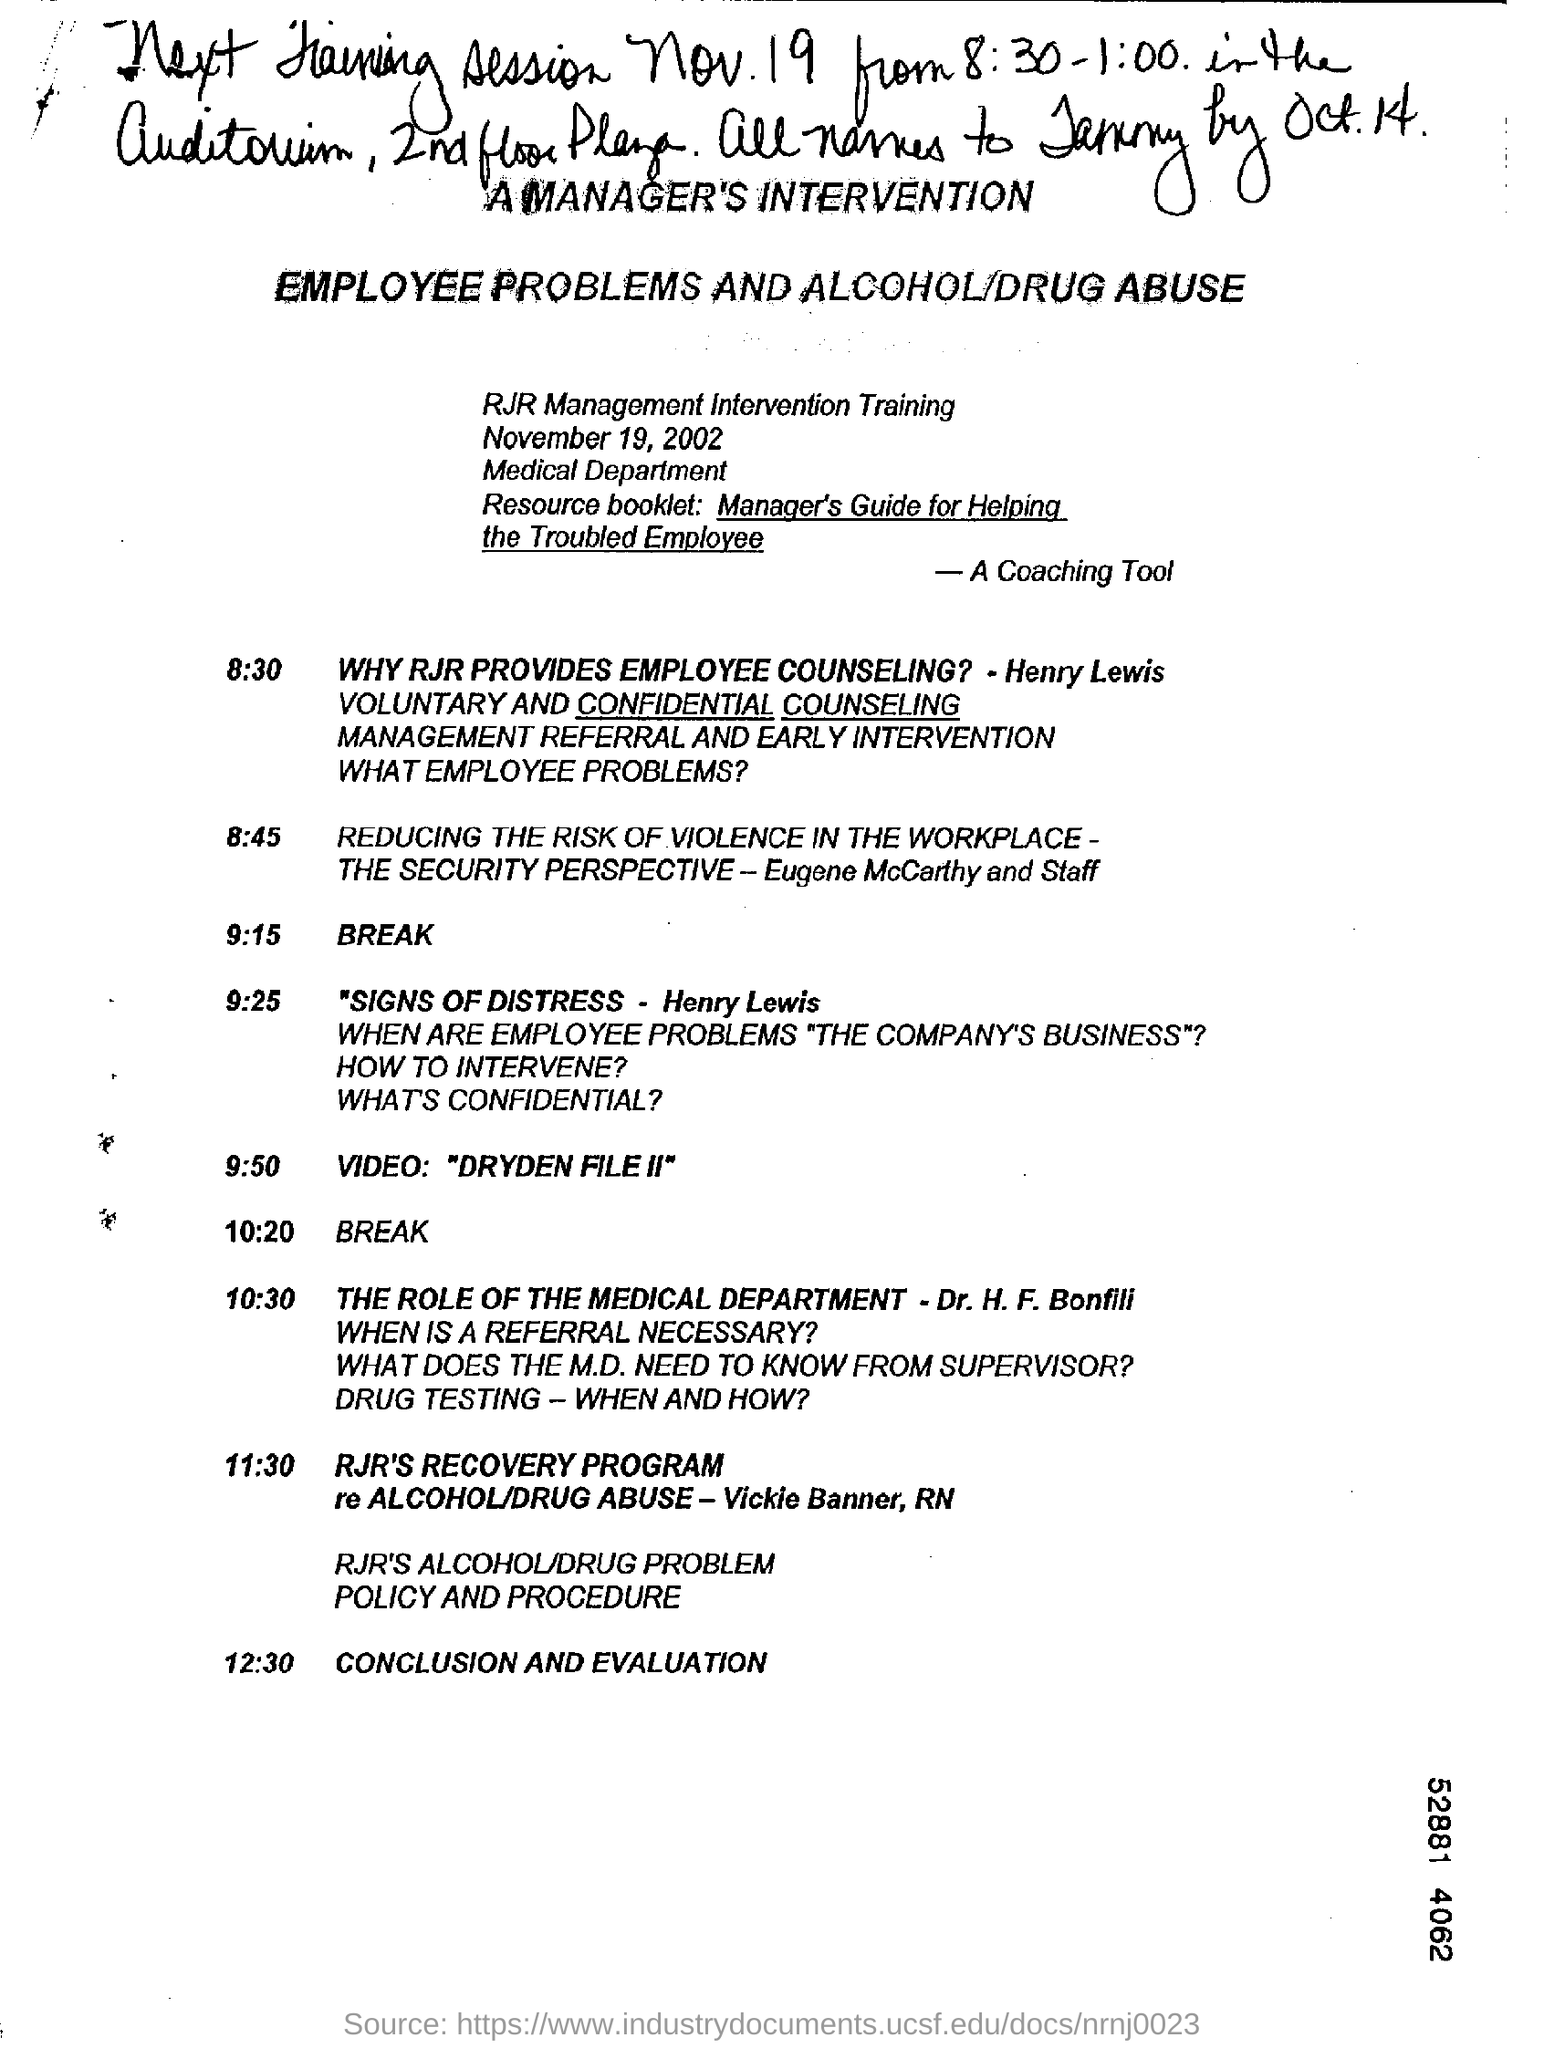Which department is mentioned in the document?
Your response must be concise. Medical. When was  the intervention training is mentioned?
Offer a very short reply. November 19, 2002. What are the main problems to be discussed in the training?
Keep it short and to the point. Employee problems and Alcohol/Drug abuse. What is the video mentioned in the document?
Ensure brevity in your answer.  "DRYDEN FILE II". 